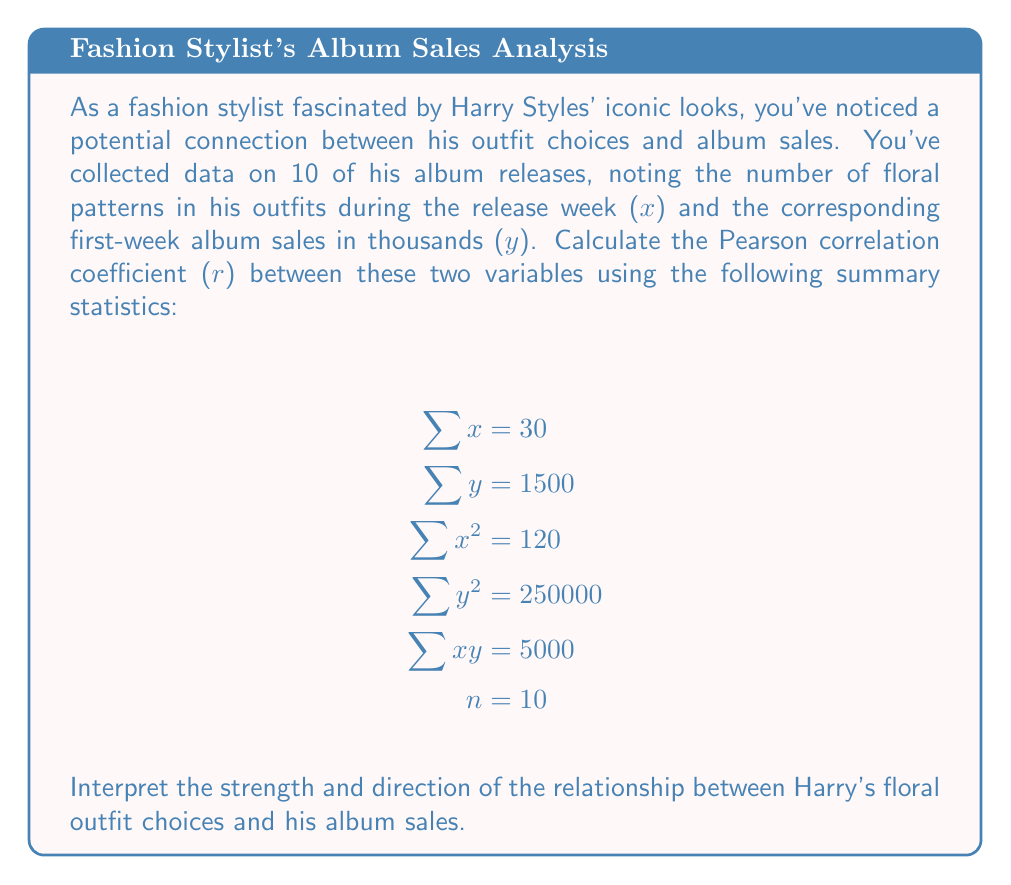Can you answer this question? To calculate the Pearson correlation coefficient (r), we'll use the formula:

$$r = \frac{n\sum xy - \sum x \sum y}{\sqrt{[n\sum x^2 - (\sum x)^2][n\sum y^2 - (\sum y)^2]}}$$

Let's substitute the given values:

1) Calculate $n\sum xy$:
   $10 * 5000 = 50000$

2) Calculate $\sum x \sum y$:
   $30 * 1500 = 45000$

3) Calculate the numerator:
   $50000 - 45000 = 5000$

4) For the denominator, first calculate:
   $n\sum x^2 = 10 * 120 = 1200$
   $(\sum x)^2 = 30^2 = 900$
   $n\sum y^2 = 10 * 250000 = 2500000$
   $(\sum y)^2 = 1500^2 = 2250000$

5) Complete the denominator calculation:
   $\sqrt{(1200 - 900)(2500000 - 2250000)}$
   $= \sqrt{300 * 250000}$
   $= \sqrt{75000000}$
   $= 8660.25$

6) Finally, calculate r:
   $r = \frac{5000}{8660.25} \approx 0.5774$

The correlation coefficient is approximately 0.5774. This indicates a moderate positive correlation between the number of floral patterns in Harry Styles' outfits during album release weeks and his first-week album sales. As the number of floral patterns increases, there tends to be a moderate increase in album sales.
Answer: $r \approx 0.5774$, indicating a moderate positive correlation 